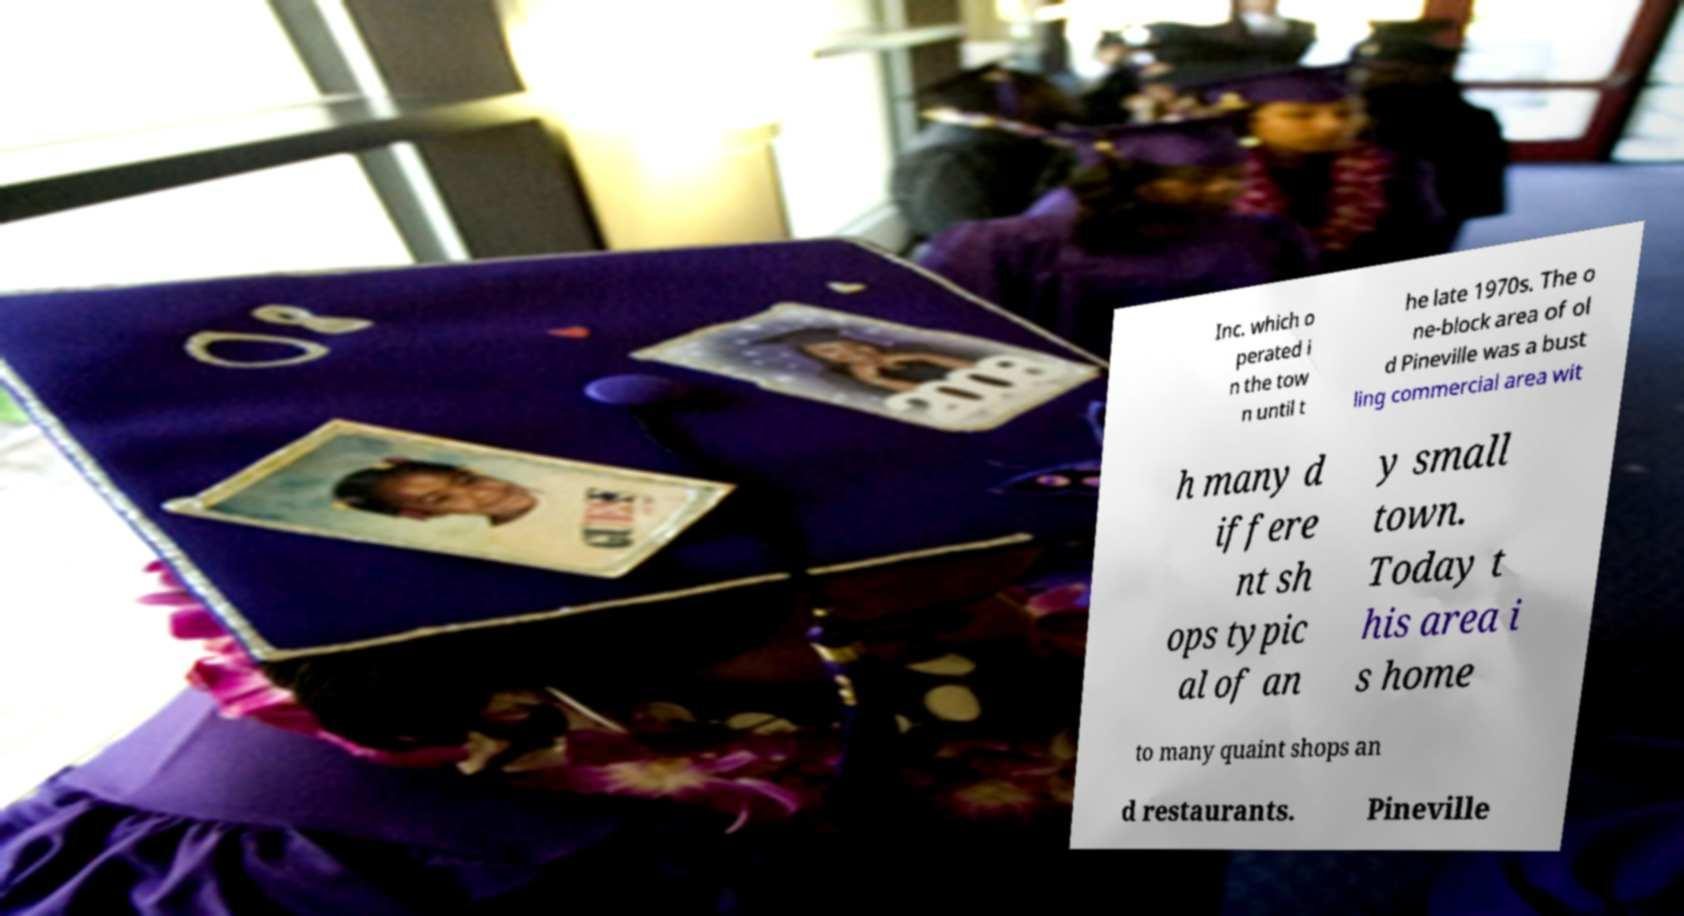Could you assist in decoding the text presented in this image and type it out clearly? Inc. which o perated i n the tow n until t he late 1970s. The o ne-block area of ol d Pineville was a bust ling commercial area wit h many d iffere nt sh ops typic al of an y small town. Today t his area i s home to many quaint shops an d restaurants. Pineville 